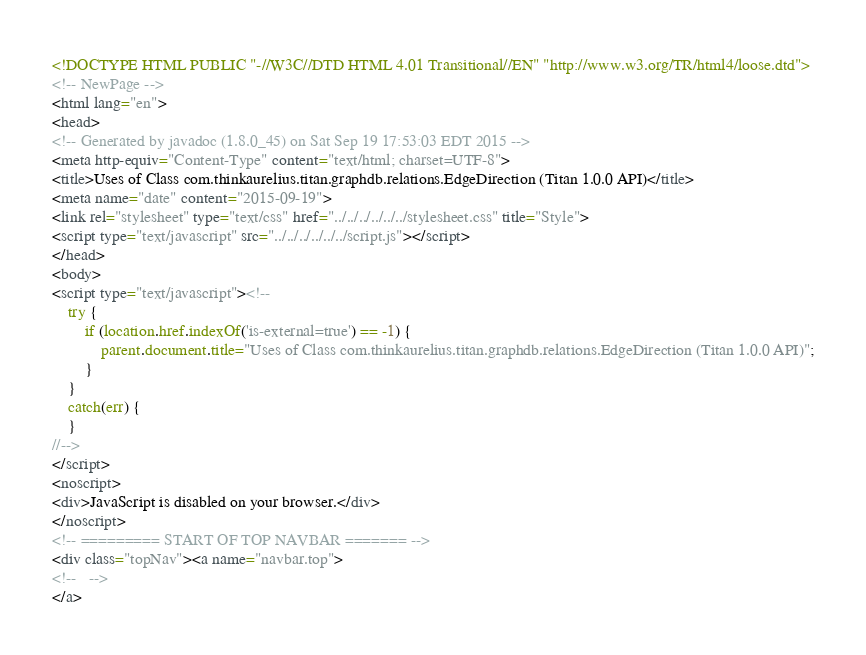Convert code to text. <code><loc_0><loc_0><loc_500><loc_500><_HTML_><!DOCTYPE HTML PUBLIC "-//W3C//DTD HTML 4.01 Transitional//EN" "http://www.w3.org/TR/html4/loose.dtd">
<!-- NewPage -->
<html lang="en">
<head>
<!-- Generated by javadoc (1.8.0_45) on Sat Sep 19 17:53:03 EDT 2015 -->
<meta http-equiv="Content-Type" content="text/html; charset=UTF-8">
<title>Uses of Class com.thinkaurelius.titan.graphdb.relations.EdgeDirection (Titan 1.0.0 API)</title>
<meta name="date" content="2015-09-19">
<link rel="stylesheet" type="text/css" href="../../../../../../stylesheet.css" title="Style">
<script type="text/javascript" src="../../../../../../script.js"></script>
</head>
<body>
<script type="text/javascript"><!--
    try {
        if (location.href.indexOf('is-external=true') == -1) {
            parent.document.title="Uses of Class com.thinkaurelius.titan.graphdb.relations.EdgeDirection (Titan 1.0.0 API)";
        }
    }
    catch(err) {
    }
//-->
</script>
<noscript>
<div>JavaScript is disabled on your browser.</div>
</noscript>
<!-- ========= START OF TOP NAVBAR ======= -->
<div class="topNav"><a name="navbar.top">
<!--   -->
</a></code> 